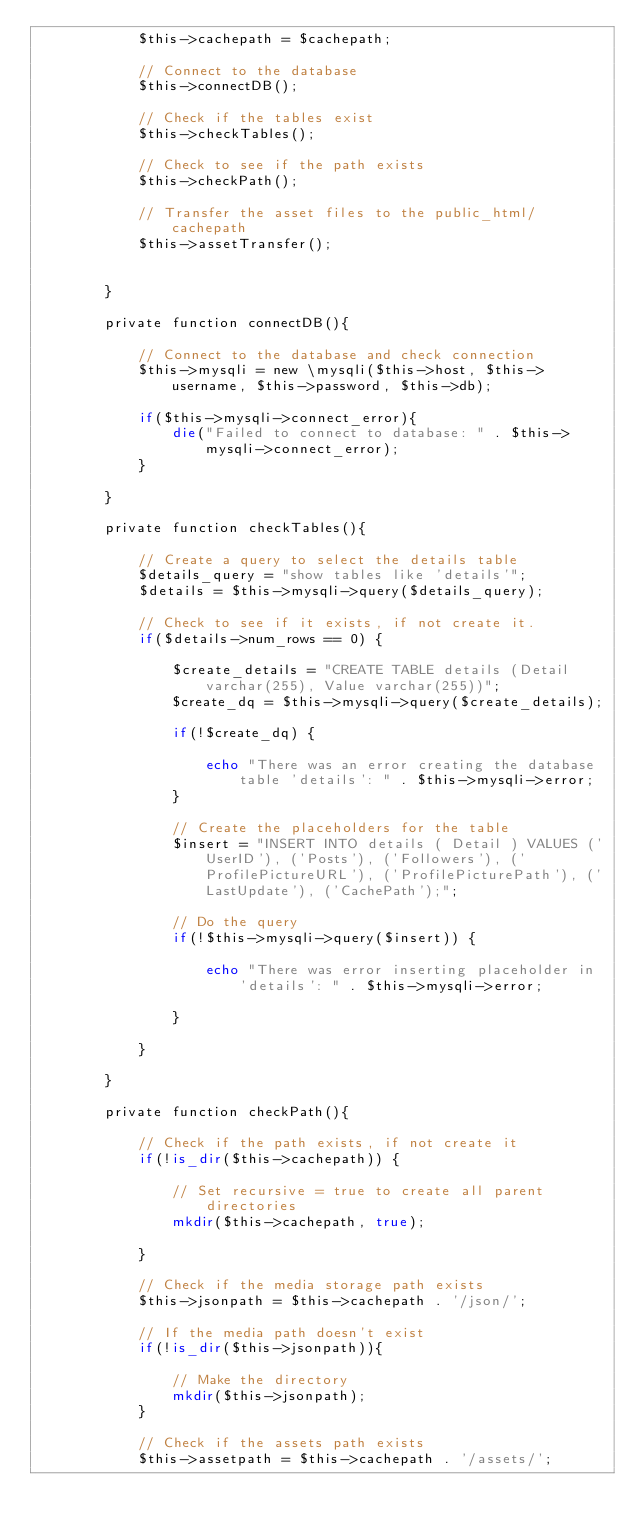Convert code to text. <code><loc_0><loc_0><loc_500><loc_500><_PHP_>			$this->cachepath = $cachepath;

			// Connect to the database
			$this->connectDB();

			// Check if the tables exist
			$this->checkTables();

			// Check to see if the path exists
			$this->checkPath();

			// Transfer the asset files to the public_html/cachepath
			$this->assetTransfer();


		}

		private function connectDB(){

			// Connect to the database and check connection
			$this->mysqli = new \mysqli($this->host, $this->username, $this->password, $this->db);

			if($this->mysqli->connect_error){
				die("Failed to connect to database: " . $this->mysqli->connect_error);
			} 

		}

		private function checkTables(){

			// Create a query to select the details table
			$details_query = "show tables like 'details'";
			$details = $this->mysqli->query($details_query);

			// Check to see if it exists, if not create it.
			if($details->num_rows == 0) {

				$create_details = "CREATE TABLE details (Detail varchar(255), Value varchar(255))";
				$create_dq = $this->mysqli->query($create_details);

				if(!$create_dq) {

					echo "There was an error creating the database table 'details': " . $this->mysqli->error;
				}

				// Create the placeholders for the table
				$insert = "INSERT INTO details ( Detail ) VALUES ('UserID'), ('Posts'), ('Followers'), ('ProfilePictureURL'), ('ProfilePicturePath'), ('LastUpdate'), ('CachePath');";

				// Do the query
				if(!$this->mysqli->query($insert)) {

					echo "There was error inserting placeholder in 'details': " . $this->mysqli->error;

				}

			}

		}

		private function checkPath(){

			// Check if the path exists, if not create it
			if(!is_dir($this->cachepath)) {

				// Set recursive = true to create all parent directories
				mkdir($this->cachepath, true);

			}

			// Check if the media storage path exists
			$this->jsonpath = $this->cachepath . '/json/';

			// If the media path doesn't exist
			if(!is_dir($this->jsonpath)){

				// Make the directory
				mkdir($this->jsonpath);
			}

			// Check if the assets path exists
			$this->assetpath = $this->cachepath . '/assets/';
</code> 